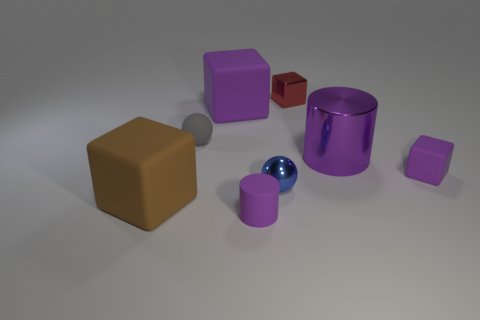Add 1 purple matte balls. How many objects exist? 9 Subtract all balls. How many objects are left? 6 Add 7 tiny matte spheres. How many tiny matte spheres are left? 8 Add 7 matte cylinders. How many matte cylinders exist? 8 Subtract 1 blue spheres. How many objects are left? 7 Subtract all blue things. Subtract all big rubber things. How many objects are left? 5 